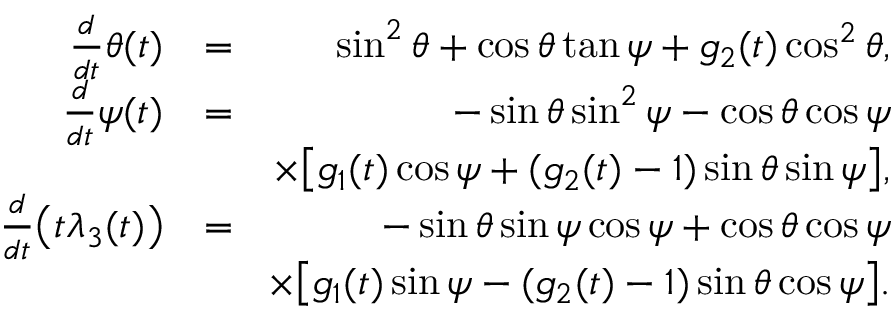Convert formula to latex. <formula><loc_0><loc_0><loc_500><loc_500>\begin{array} { r l r } { \frac { d } { d t } \theta ( t ) } & { = } & { \sin ^ { 2 } { \theta } + \cos { \theta } \tan { \psi } + g _ { 2 } ( t ) \cos ^ { 2 } { \theta } , } \\ { \frac { d } { d t } \psi ( t ) } & { = } & { - \sin { \theta } \sin ^ { 2 } { \psi } - \cos { \theta } \cos { \psi } } \\ & { \times \left [ g _ { 1 } ( t ) \cos { \psi } + ( g _ { 2 } ( t ) - 1 ) \sin { \theta } \sin { \psi } \right ] , } \\ { \frac { d } { d t } \left ( t \lambda _ { 3 } ( t ) \right ) } & { = } & { - \sin { \theta } \sin { \psi } \cos { \psi } + \cos { \theta } \cos { \psi } } \\ & { \, \times \left [ g _ { 1 } ( t ) \sin { \psi } - ( g _ { 2 } ( t ) - 1 ) \sin { \theta } \cos { \psi } \right ] . } \end{array}</formula> 